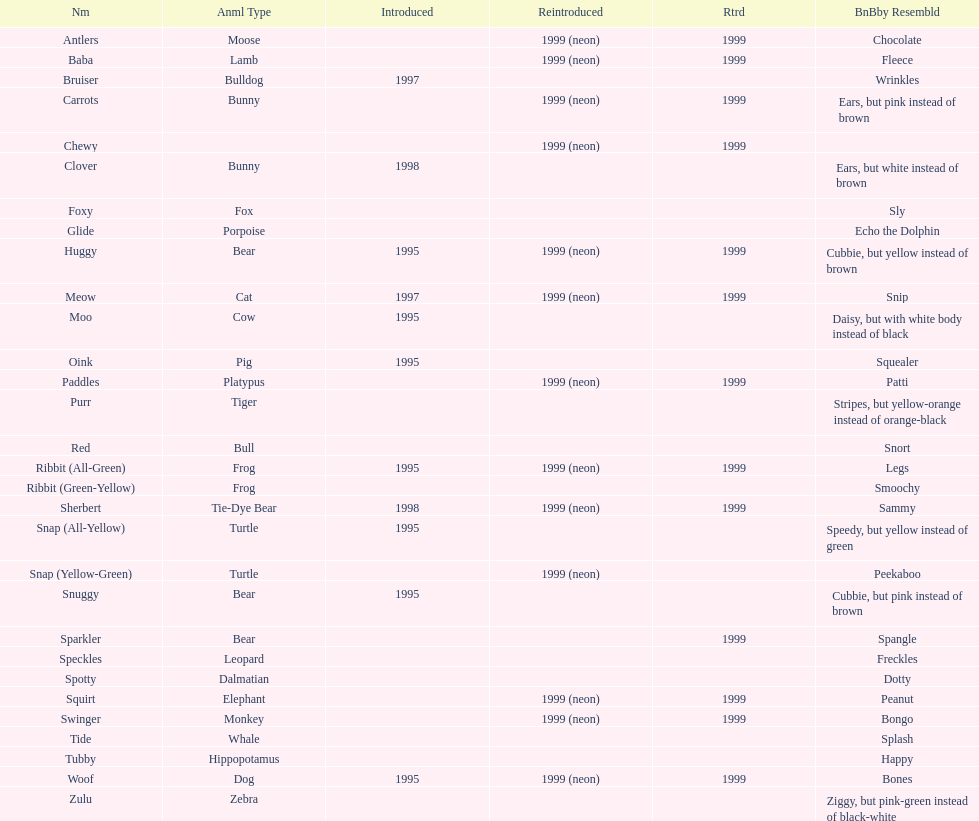What is the number of frog pillow pals? 2. 